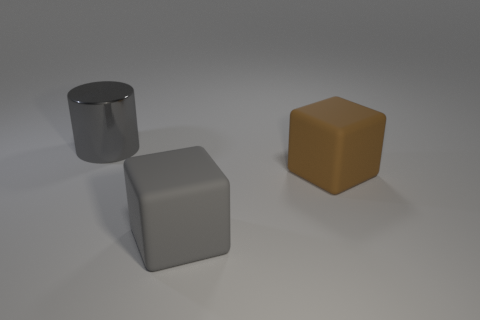Does the gray shiny thing have the same shape as the gray rubber thing?
Offer a terse response. No. What size is the rubber object that is left of the large cube behind the big gray thing on the right side of the metallic cylinder?
Your response must be concise. Large. What is the material of the other object that is the same shape as the brown matte object?
Your response must be concise. Rubber. Is there anything else that has the same size as the gray matte object?
Your answer should be very brief. Yes. What size is the thing to the left of the gray object on the right side of the big metallic object?
Offer a terse response. Large. What color is the large shiny cylinder?
Offer a very short reply. Gray. How many rubber objects are to the left of the matte thing to the right of the gray cube?
Your answer should be compact. 1. There is a matte object that is behind the gray rubber block; are there any large gray cylinders behind it?
Make the answer very short. Yes. There is a large cylinder; are there any things behind it?
Ensure brevity in your answer.  No. Is the shape of the gray object that is in front of the big metallic object the same as  the big shiny object?
Your response must be concise. No. 